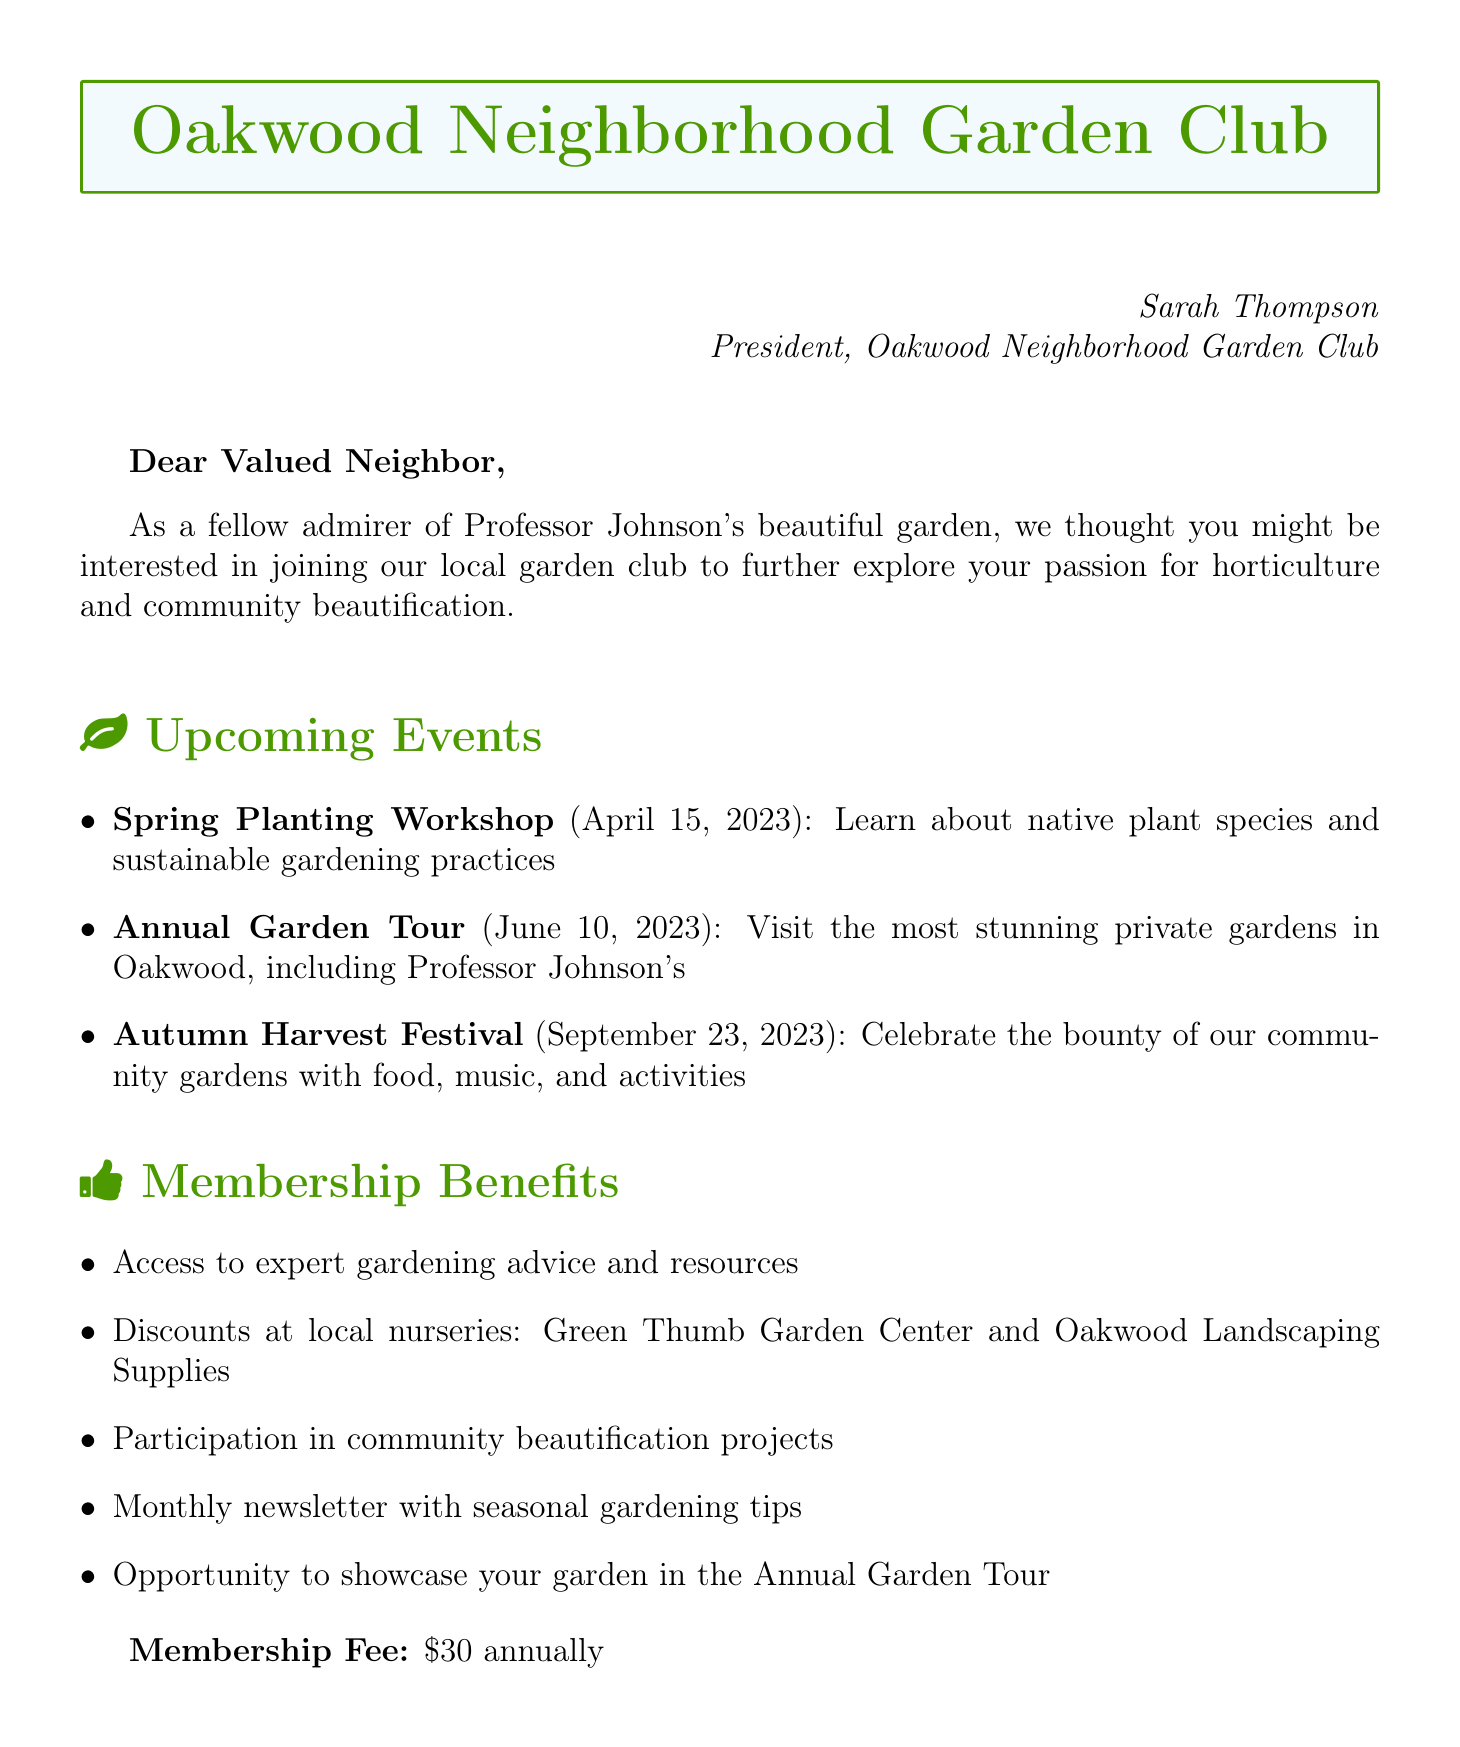What is the name of the garden club? The name of the garden club is mentioned as "Oakwood Neighborhood Garden Club" in the invitation.
Answer: Oakwood Neighborhood Garden Club When do the club meetings occur? The meeting frequency, stated in the document, is every second Saturday of the month.
Answer: Monthly, every second Saturday What is the membership fee? The document specifies the membership fee as an annual amount.
Answer: $30 Who is the president of the garden club? The president's name is provided in the sender information.
Answer: Sarah Thompson What is one upcoming event in April? The document lists the Spring Planting Workshop, which is scheduled for April 15, 2023.
Answer: Spring Planting Workshop How many membership benefits are listed in the document? By counting the items in the membership benefits section, we can determine how many are available.
Answer: Five Which local nurseries offer membership discounts? The document specifies the names of the local nurseries that provide discounts to members.
Answer: Green Thumb Garden Center and Oakwood Landscaping Supplies What is one eco-friendly initiative mentioned? One of the eco-friendly initiatives listed in the document is related to pollinator-friendly designs.
Answer: Pollinator-friendly garden designs Who provided a testimonial in the document? A testimonial is quoted in the document and the name of the person who provided it is mentioned.
Answer: Emily Chen 